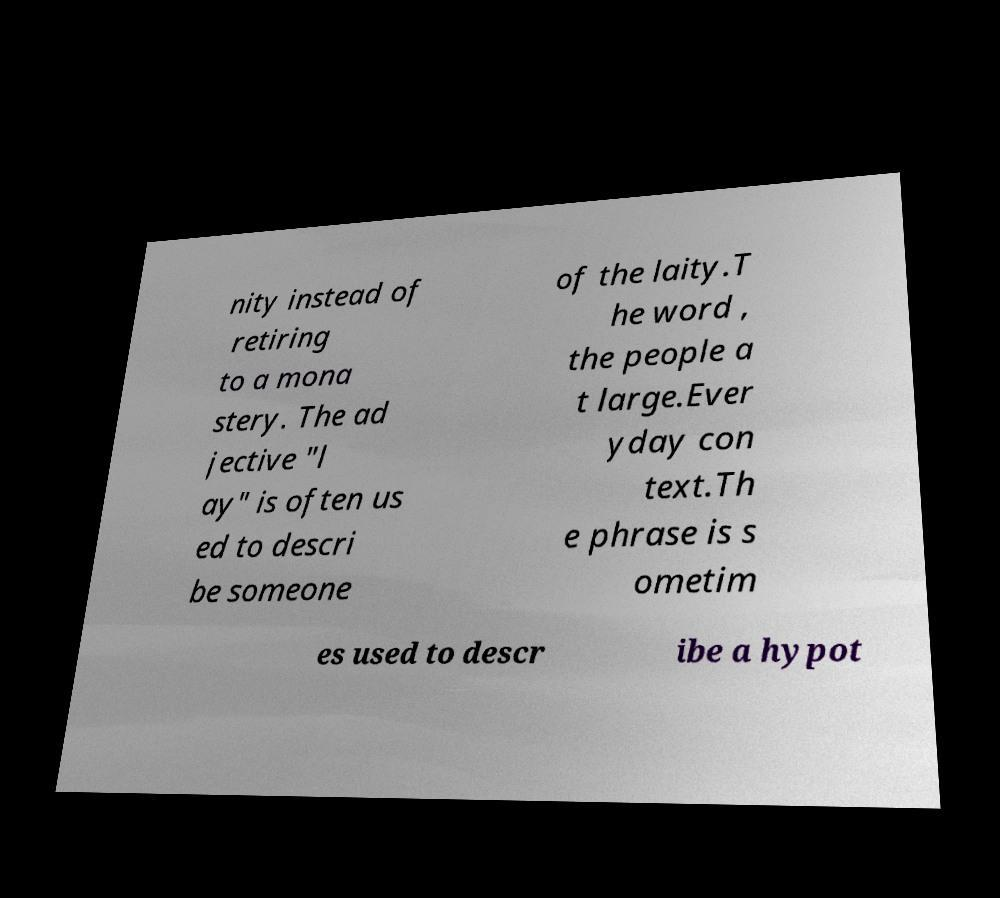Can you read and provide the text displayed in the image?This photo seems to have some interesting text. Can you extract and type it out for me? nity instead of retiring to a mona stery. The ad jective "l ay" is often us ed to descri be someone of the laity.T he word , the people a t large.Ever yday con text.Th e phrase is s ometim es used to descr ibe a hypot 